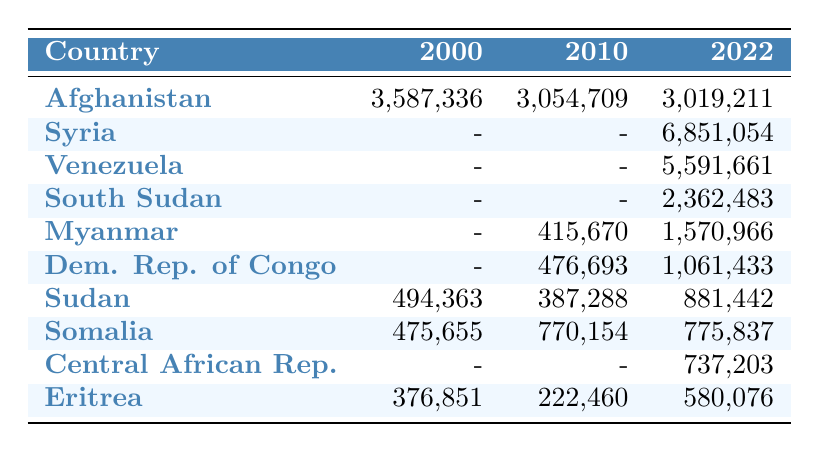What was the refugee population from Afghanistan in 2000? In the table, under the year 2000, the refugee population for Afghanistan is stated directly as 3,587,336.
Answer: 3,587,336 Which country had the highest refugee population in 2022? Looking at the year 2022 in the table, Syria has the highest refugee population listed, which is 6,851,054.
Answer: Syria What is the difference in the refugee population from Sudan between 2000 and 2022? To find the difference, subtract the 2000 refugee population of Sudan (494,363) from the 2022 population (881,442): 881,442 - 494,363 = 387,079.
Answer: 387,079 Did the refugee population from Eritrea increase or decrease from 2010 to 2022? In 2010, Eritrea had a refugee population of 222,460. By 2022, it had increased to 580,076. Therefore, the population increased.
Answer: Increased What was the total refugee population from the top three countries in 2022? The top three countries by refugee population in 2022 are Syria (6,851,054), Venezuela (5,591,661), and Afghanistan (3,019,211). To find the total, we add these numbers together: 6,851,054 + 5,591,661 + 3,019,211 = 15,461,926.
Answer: 15,461,926 Is there any country listed in 2000 that does not appear in 2022? Reviewing the table, while several countries are listed in 2000, such as Bosnia and Herzegovina and Burundi, they do not appear in the 2022 data. Therefore, the answer is yes.
Answer: Yes What is the average refugee population from Myanmar across the years presented? The refugee population from Myanmar is given as 415,670 for 2010 and 1,570,966 for 2022. To find the average, we add these two numbers: 415,670 + 1,570,966 = 1,986,636, then divide by 2: 1,986,636 / 2 = 993,318.
Answer: 993,318 Which two countries had the lowest refugee populations in 2000? The table indicates Angola (433,760) and Sierra Leone (401,456) had the two lowest refugee populations in 2000, as compared to other countries.
Answer: Angola and Sierra Leone What was the refugee population change for Somalia from 2010 to 2022? Somalia's refugee population was 770,154 in 2010 and 775,837 in 2022. To find the change, subtract 2010's population from 2022's: 775,837 - 770,154 = 5,683.
Answer: 5,683 Are there any countries that had no reported refugee population in 2000? By examining the table, we can see that in 2000, countries like Syria, Venezuela, South Sudan, and the Central African Republic are not listed, indicating no reported refugee populations for those countries that year.
Answer: Yes 